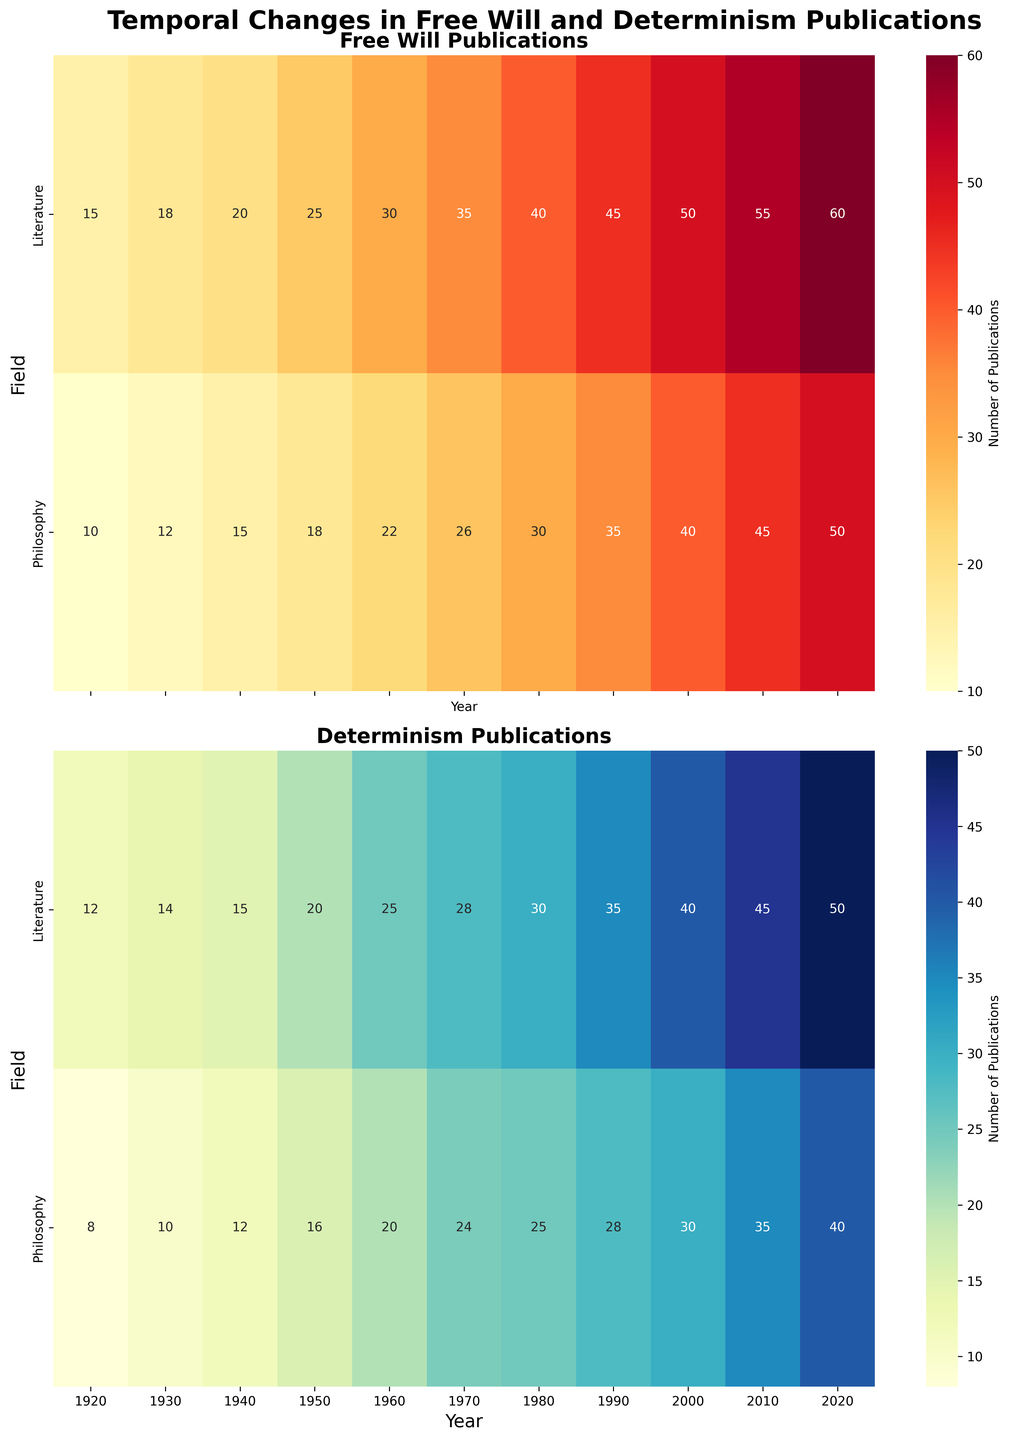What's the title of the figure? The title is located at the top center of the plot, providing a brief description of what the figure represents.
Answer: Temporal Changes in Free Will and Determinism Publications What field had the highest number of Free Will publications in 2020? Check the Free Will heatmap for the year 2020 and find the field with the darkest red color, which indicates the highest number of publications.
Answer: Literature How many Free Will publications were there in Literature in 1950? Locate the intersection of the Literature row and the 1950 column in the Free Will heatmap, which contains the exact number.
Answer: 25 Compare the trend of Determinism publications in Philosophy from 1920 to 2020. The trend can be observed by tracing the color changes in the Philosophy row of the Determinism heatmap from 1920 to 2020. Note how the shades of blue become increasingly darker, indicating more publications over time.
Answer: Increasing trend Which decade saw the highest increase in Free Will publications in Philosophy? Compare the changes in publication numbers for each decade in the Philosophy row of the Free Will heatmap. Look for the decade where the increase is the largest.
Answer: 2010-2020 What was the total number of Determinism publications in Literature in the year 2000? Locate the intersection of the Literature row and the 2000 column in the Determinism heatmap to find the exact number.
Answer: 40 Between Literature and Philosophy, which field had a greater number of Free Will publications in 1980? Compare the numbers at the intersection of the 1980 column in both the Literature and Philosophy rows of the Free Will heatmap.
Answer: Literature By how much did Free Will publications in Philosophy increase from 1930 to 1960? Subtract the number of publications in 1930 from 1960 in the Philosophy row of the Free Will heatmap: 22 (1960) - 12 (1930) = 10.
Answer: 10 Is the distribution of publications more consistent (less variation) for Free Will or Determinism in Literature? Compare the spread and color gradients of the two heatmaps for Literature to determine which has less variation over the time period.
Answer: Free Will Which year had the lowest number of Determinism publications in Philosophy? Identify the lightest blue color in the Philosophy row of the Determinism heatmap and note the corresponding year.
Answer: 1920 